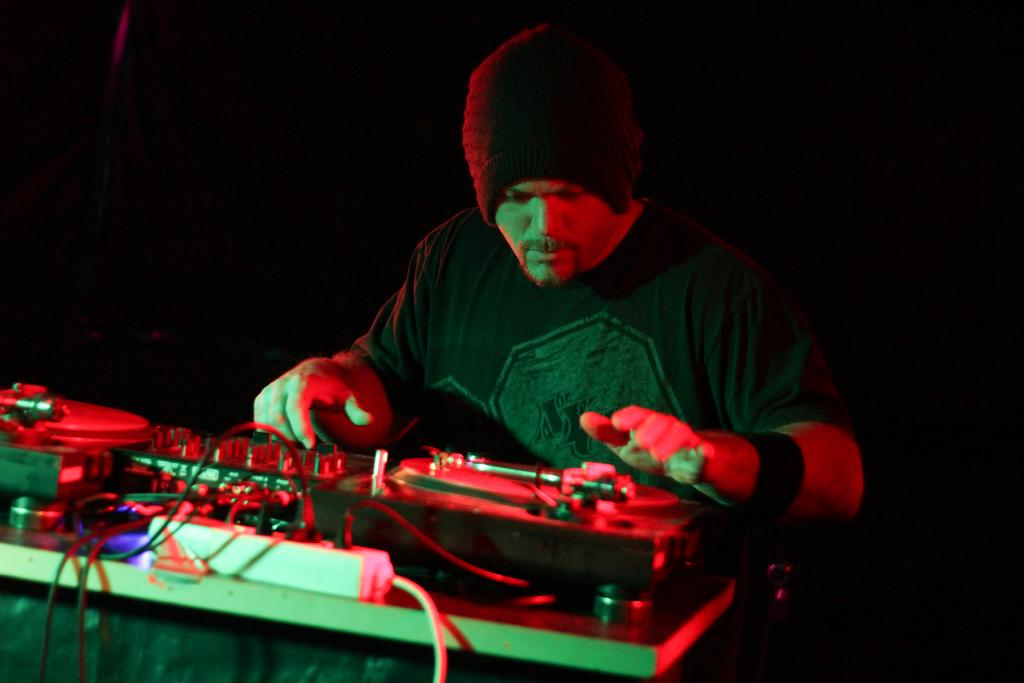What is the main subject of the image? The main subject of the image is a man. What is the man doing in the image? The man is controlling a DJ console in the image. Where is the DJ console located? The DJ console is on a table in the image. What can be observed about the background of the image? The background of the image is dark. How many pizzas are being served in the image? There are no pizzas present in the image. What type of office equipment can be seen in the image? There is no office equipment present in the image; it features a man controlling a DJ console. 